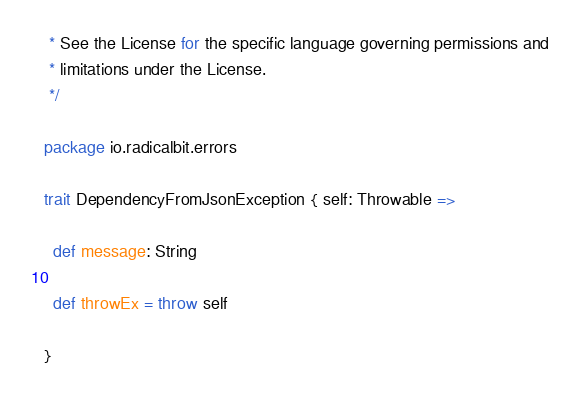Convert code to text. <code><loc_0><loc_0><loc_500><loc_500><_Scala_> * See the License for the specific language governing permissions and
 * limitations under the License.
 */

package io.radicalbit.errors

trait DependencyFromJsonException { self: Throwable =>

  def message: String

  def throwEx = throw self

}
</code> 